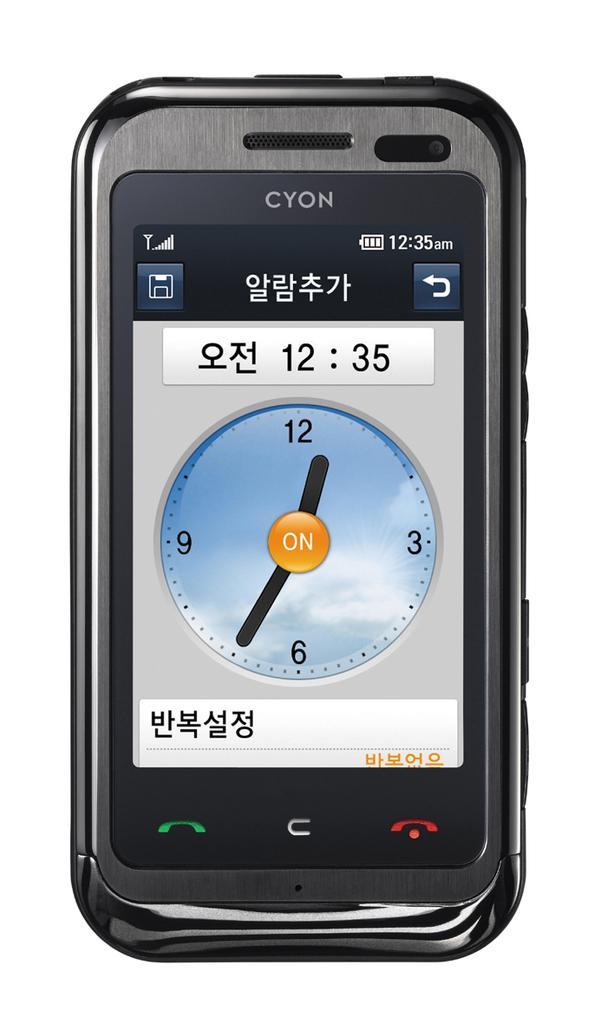<image>
Write a terse but informative summary of the picture. A black CYON smartphone, with a homepage of an analog clock showing 12:35, and writing that is in characters rather than the alphabet. 